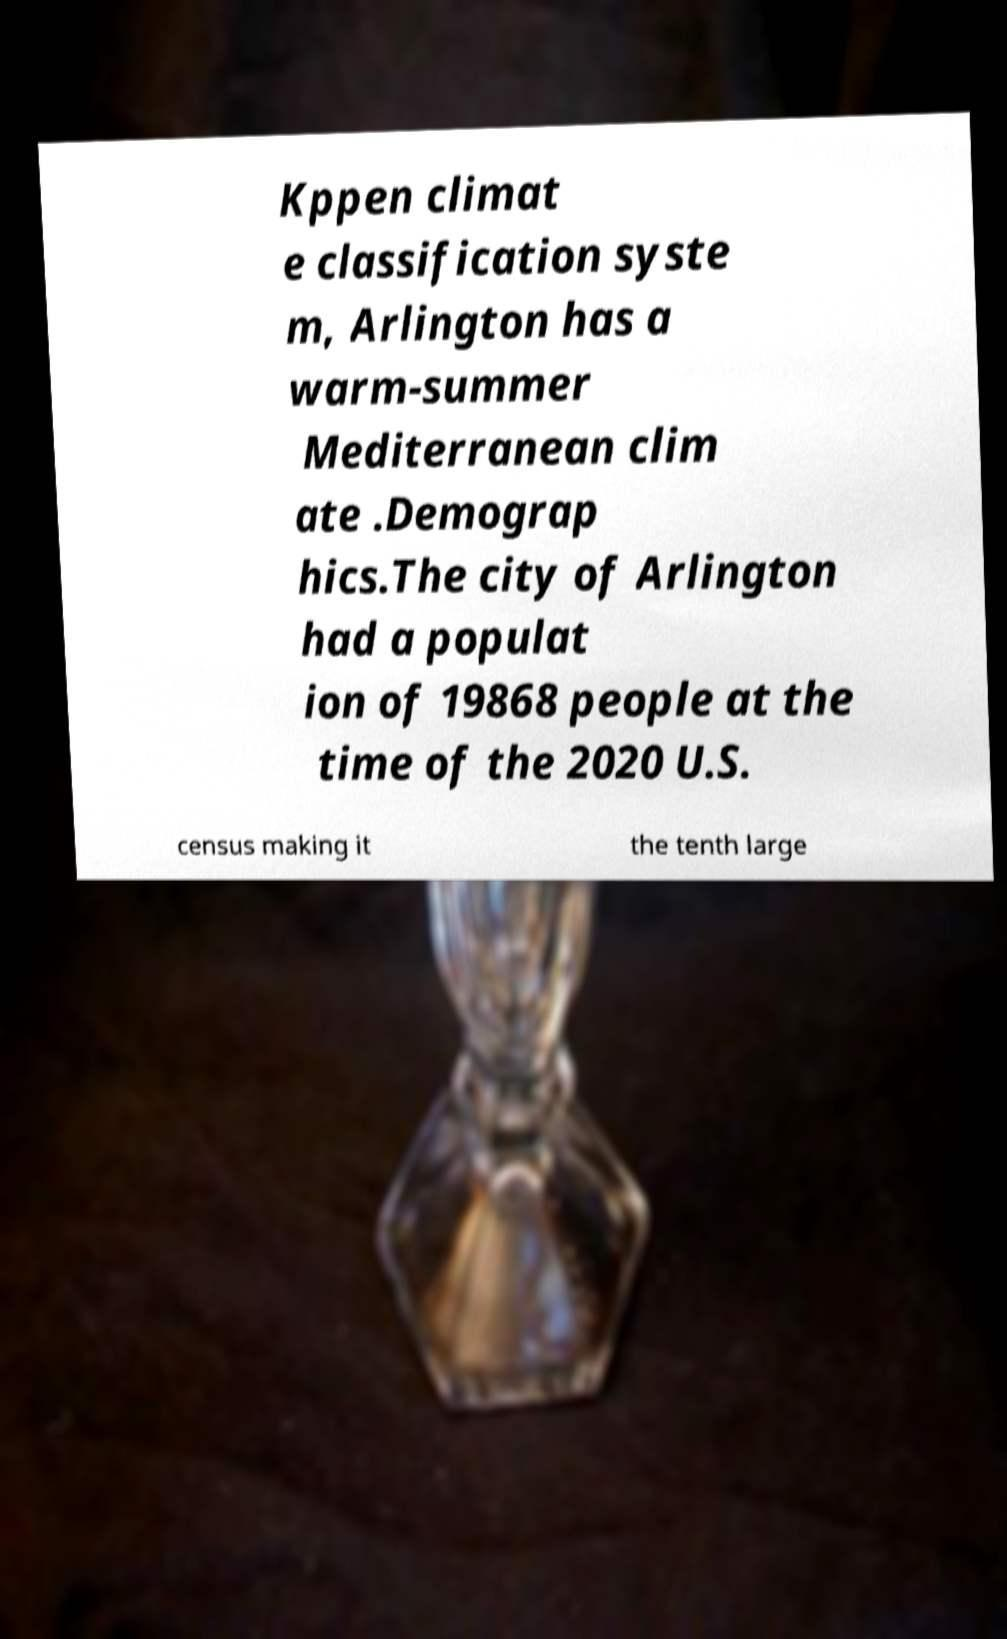Please read and relay the text visible in this image. What does it say? Kppen climat e classification syste m, Arlington has a warm-summer Mediterranean clim ate .Demograp hics.The city of Arlington had a populat ion of 19868 people at the time of the 2020 U.S. census making it the tenth large 